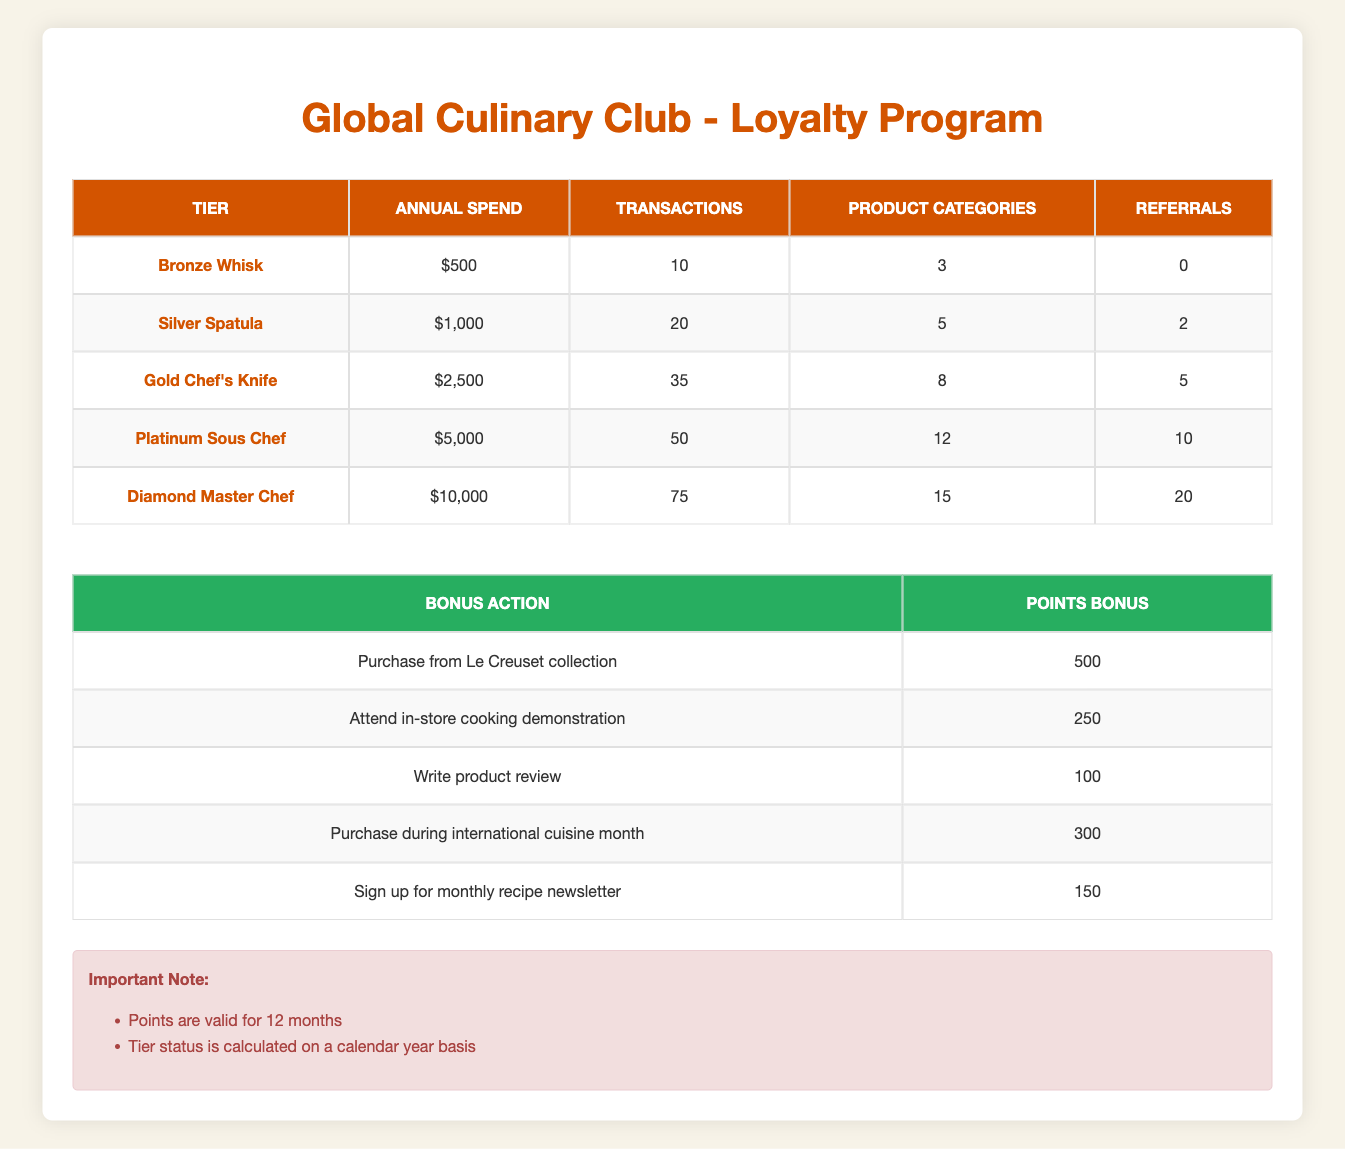What is the annual spend required to qualify for the Gold Chef's Knife tier? The table states that the requirement for the Gold Chef's Knife tier is an annual spend of $2,500.
Answer: $2,500 Is it true that referrals are part of the qualification criteria for the Silver Spatula tier? Yes, the table shows that to qualify for the Silver Spatula tier, a customer needs to refer 2 people.
Answer: Yes How many transactions are needed to qualify for the Platinum Sous Chef tier? According to the table, customers need to complete 50 transactions to qualify for the Platinum Sous Chef tier.
Answer: 50 What is the total annual spend required to achieve both the Bronze Whisk and Silver Spatula tiers? The annual spend for the Bronze Whisk tier is $500, and for the Silver Spatula tier, it is $1,000. Summing these two amounts gives $500 + $1,000 = $1,500.
Answer: $1,500 How many product categories does a customer need to qualify for the Diamond Master Chef tier? The table indicates that a customer must purchase from 15 product categories to qualify for the Diamond Master Chef tier.
Answer: 15 If a customer only reaches the Gold Chef's Knife tier, how many more referrals do they need to qualify for the Platinum Sous Chef tier? The Gold Chef's Knife tier requires 5 referrals, while the Platinum Sous Chef tier requires 10 referrals. The difference is 10 - 5 = 5 more referrals needed.
Answer: 5 What is the points bonus for attending an in-store cooking demonstration? The table specifies that attending an in-store cooking demonstration grants a points bonus of 250.
Answer: 250 Is it accurate to say that a customer must spend $10,000 to qualify for any level of the loyalty program? No, the Bronze Whisk tier requires only $500, meaning not all tiers require a $10,000 spend.
Answer: No If a customer refers 10 people and purchases during international cuisine month, what is their total points bonus for these actions? Referring 10 people meets the requirement for the Platinum Sous Chef tier and adds 10 referrals that earns 10 points each (if considered for tier qualification) but not points bonus directly. Purchasing during international cuisine month adds 300 points. Hence, the total points bonus for this action is 300.
Answer: 300 